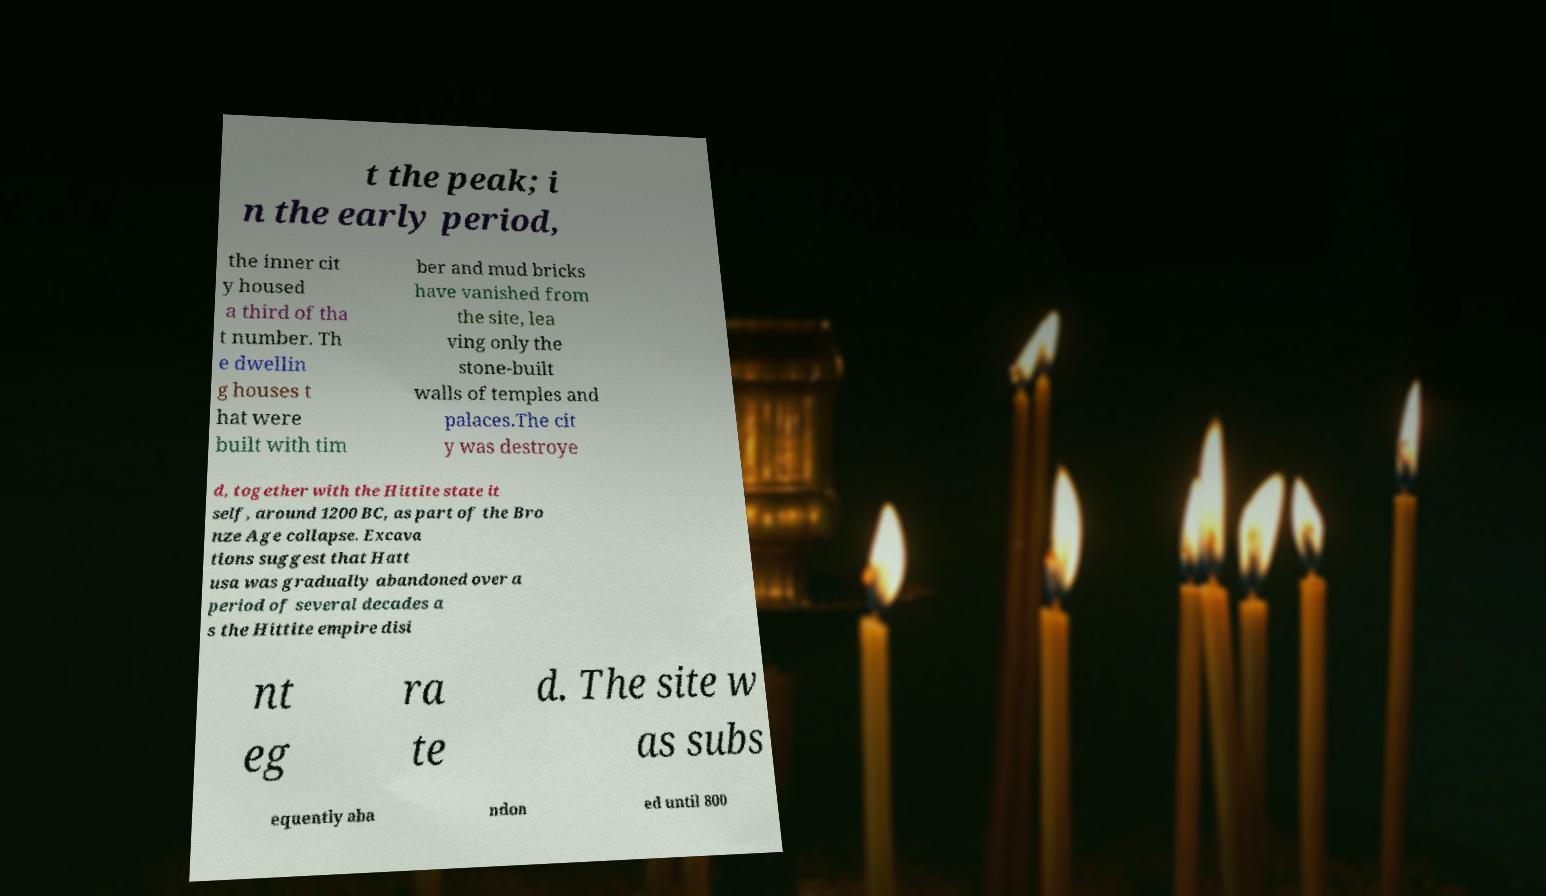Please read and relay the text visible in this image. What does it say? t the peak; i n the early period, the inner cit y housed a third of tha t number. Th e dwellin g houses t hat were built with tim ber and mud bricks have vanished from the site, lea ving only the stone-built walls of temples and palaces.The cit y was destroye d, together with the Hittite state it self, around 1200 BC, as part of the Bro nze Age collapse. Excava tions suggest that Hatt usa was gradually abandoned over a period of several decades a s the Hittite empire disi nt eg ra te d. The site w as subs equently aba ndon ed until 800 